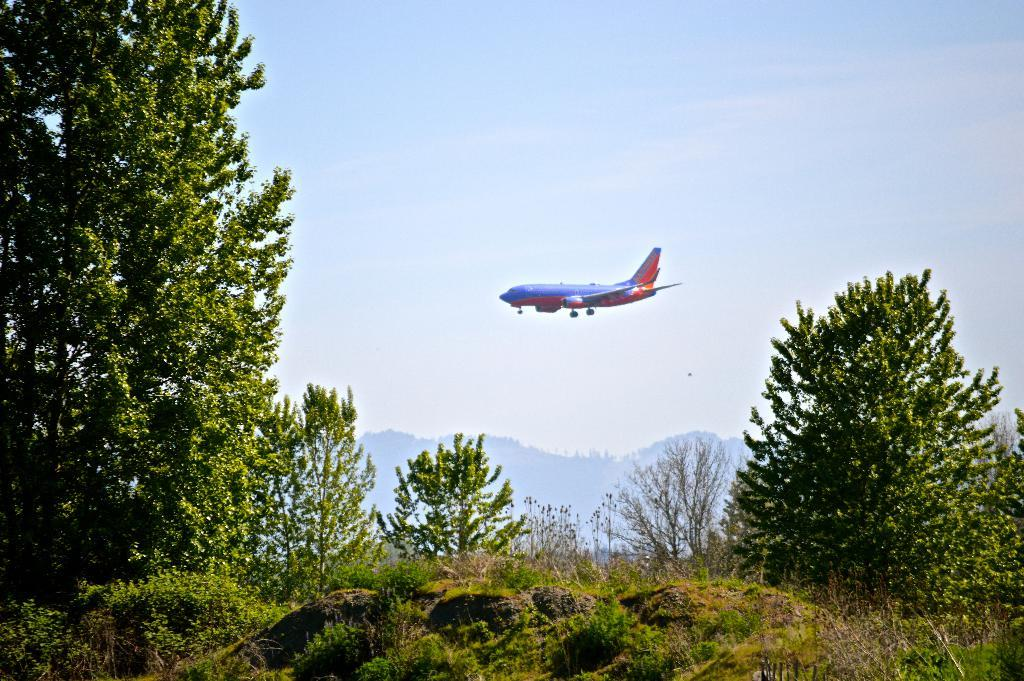What type of vegetation can be seen in the image? There is grass and trees in the image. What type of landscape feature is visible in the image? There are mountains in the image. What else is present in the image besides the natural elements? There is an airplane in the image. What can be seen in the background of the image? The sky is visible in the background of the image. What time of day might the image have been taken? The image is likely taken during the day, as the sky is visible and not dark. What type of stem can be seen growing from the table in the image? There is no table or stem present in the image. How fast can the airplane run in the image? Airplanes do not run; they fly. Additionally, there is no indication of the airplane's speed in the image. 